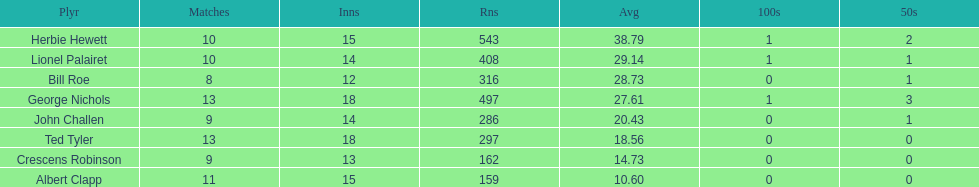Name a player whose average was above 25. Herbie Hewett. 